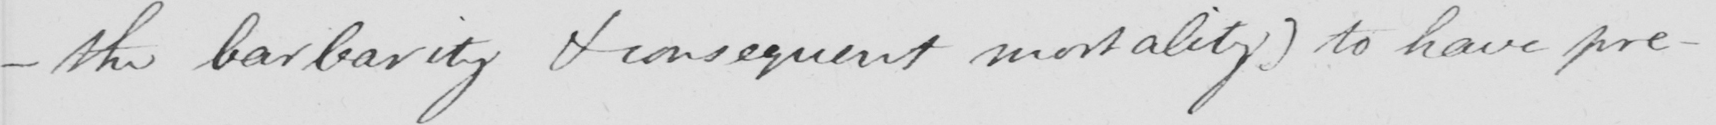Can you tell me what this handwritten text says? _  the barbarity & consequent mortality )  to have pre- 